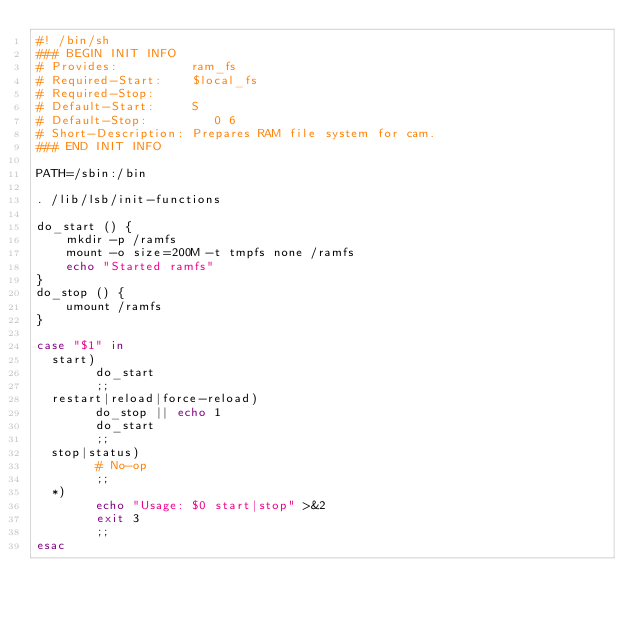Convert code to text. <code><loc_0><loc_0><loc_500><loc_500><_Bash_>#! /bin/sh
### BEGIN INIT INFO
# Provides:          ram_fs
# Required-Start:    $local_fs
# Required-Stop:
# Default-Start:     S
# Default-Stop:         0 6
# Short-Description: Prepares RAM file system for cam.
### END INIT INFO

PATH=/sbin:/bin

. /lib/lsb/init-functions

do_start () {
    mkdir -p /ramfs
    mount -o size=200M -t tmpfs none /ramfs
    echo "Started ramfs"
}
do_stop () {
    umount /ramfs
}

case "$1" in
  start)
        do_start
        ;;
  restart|reload|force-reload)
        do_stop || echo 1
        do_start
        ;;
  stop|status)
        # No-op
        ;;
  *)
        echo "Usage: $0 start|stop" >&2
        exit 3
        ;;
esac
</code> 